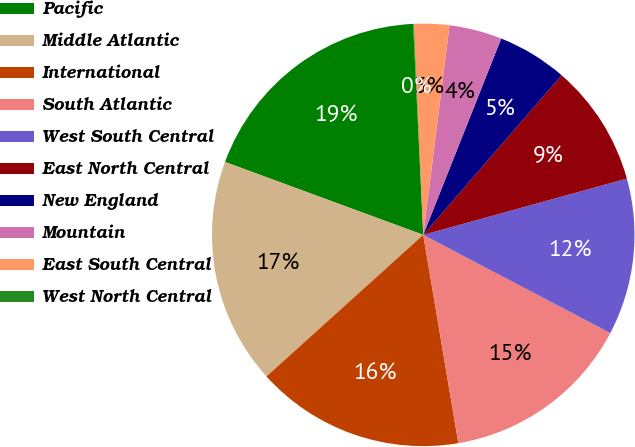Convert chart to OTSL. <chart><loc_0><loc_0><loc_500><loc_500><pie_chart><fcel>Pacific<fcel>Middle Atlantic<fcel>International<fcel>South Atlantic<fcel>West South Central<fcel>East North Central<fcel>New England<fcel>Mountain<fcel>East South Central<fcel>West North Central<nl><fcel>18.63%<fcel>17.3%<fcel>15.97%<fcel>14.65%<fcel>11.99%<fcel>9.34%<fcel>5.35%<fcel>4.03%<fcel>2.7%<fcel>0.05%<nl></chart> 